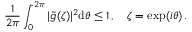<formula> <loc_0><loc_0><loc_500><loc_500>{ \frac { 1 } { 2 \pi } } \int _ { 0 } ^ { 2 \pi } | \tilde { g } ( \zeta ) | ^ { 2 } d \theta \leq 1 \, , \quad \zeta = e x p ( i \theta ) \, .</formula> 